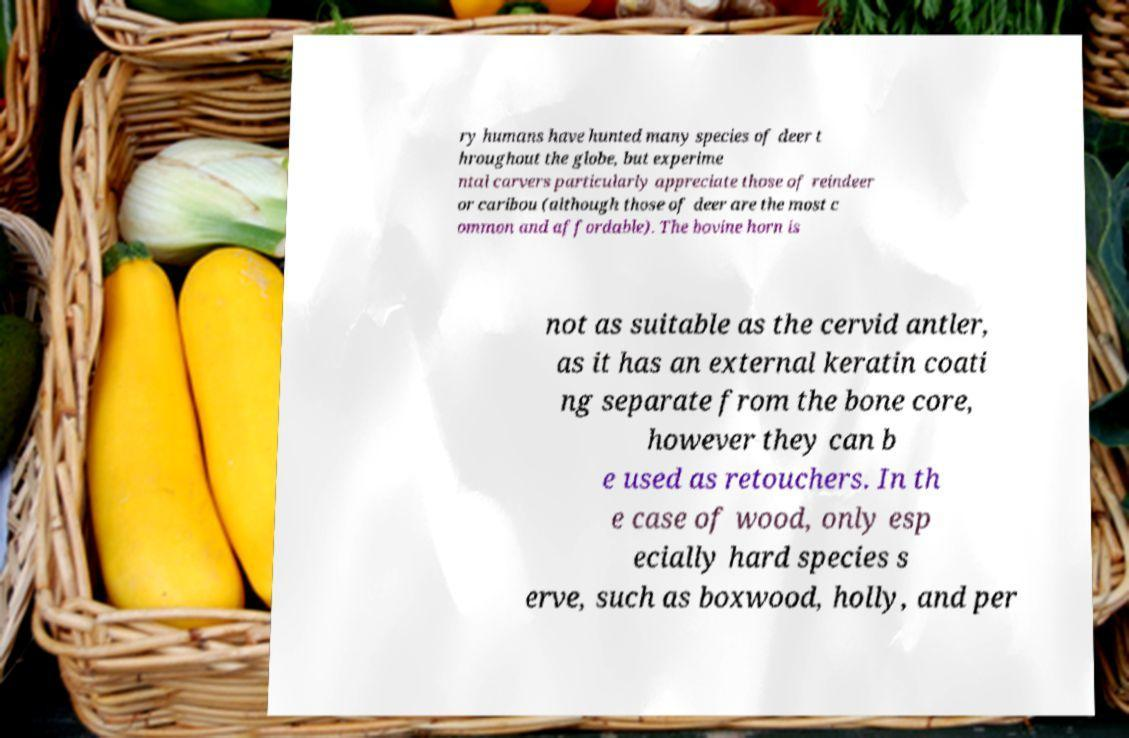Please read and relay the text visible in this image. What does it say? ry humans have hunted many species of deer t hroughout the globe, but experime ntal carvers particularly appreciate those of reindeer or caribou (although those of deer are the most c ommon and affordable). The bovine horn is not as suitable as the cervid antler, as it has an external keratin coati ng separate from the bone core, however they can b e used as retouchers. In th e case of wood, only esp ecially hard species s erve, such as boxwood, holly, and per 